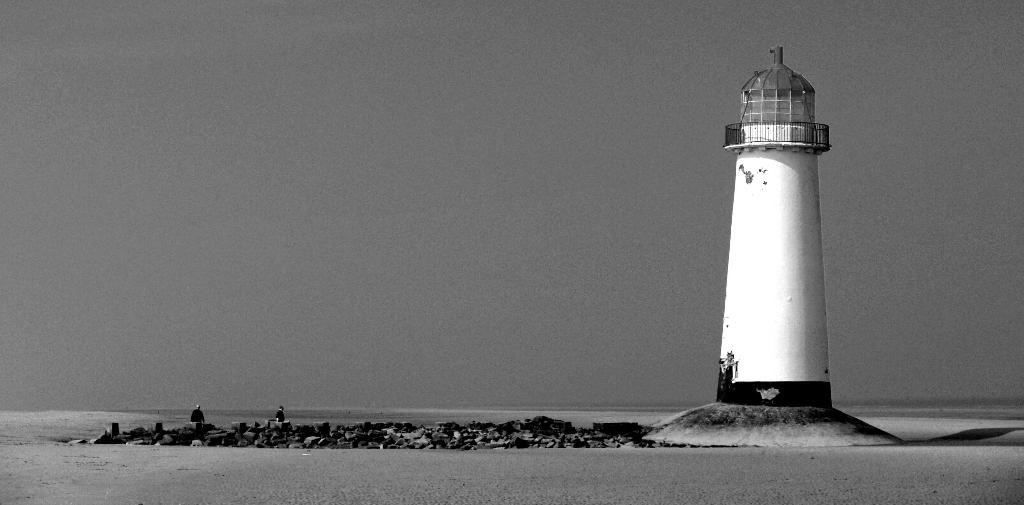What is the main structure in the image? There is a tower in the image. Are there any living beings in the image? Yes, there are people in the image. What type of natural elements can be seen in the image? There are rocks and water visible in the image. What part of the natural environment is visible in the image? The sky is visible in the image. What is the color scheme of the image? The image is black and white in color. How many marbles are on the tray in the image? There is no tray or marbles present in the image. What type of animals can be seen grazing near the water in the image? There are no animals, such as cows, present in the image. 